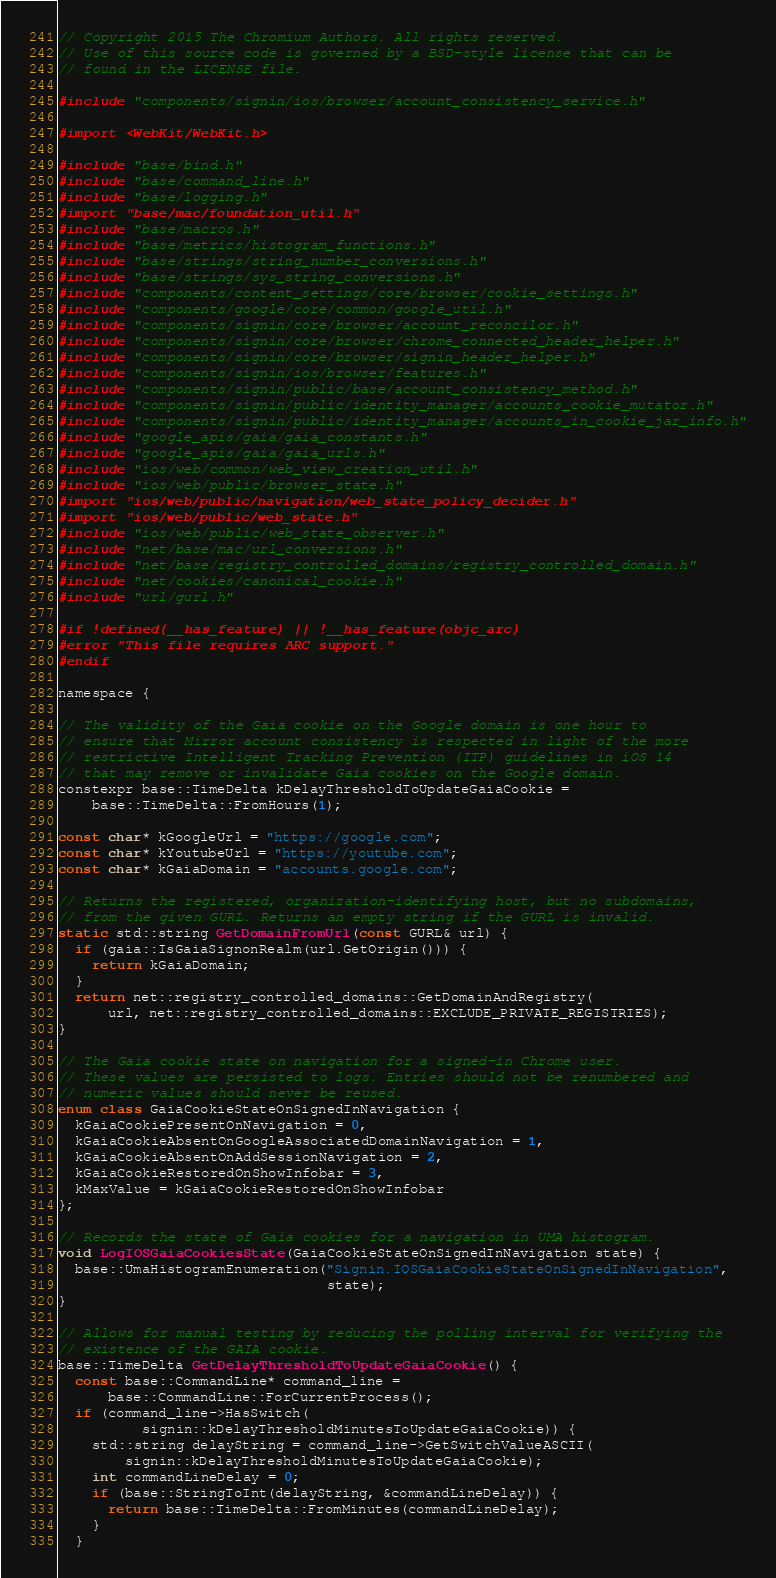<code> <loc_0><loc_0><loc_500><loc_500><_ObjectiveC_>// Copyright 2015 The Chromium Authors. All rights reserved.
// Use of this source code is governed by a BSD-style license that can be
// found in the LICENSE file.

#include "components/signin/ios/browser/account_consistency_service.h"

#import <WebKit/WebKit.h>

#include "base/bind.h"
#include "base/command_line.h"
#include "base/logging.h"
#import "base/mac/foundation_util.h"
#include "base/macros.h"
#include "base/metrics/histogram_functions.h"
#include "base/strings/string_number_conversions.h"
#include "base/strings/sys_string_conversions.h"
#include "components/content_settings/core/browser/cookie_settings.h"
#include "components/google/core/common/google_util.h"
#include "components/signin/core/browser/account_reconcilor.h"
#include "components/signin/core/browser/chrome_connected_header_helper.h"
#include "components/signin/core/browser/signin_header_helper.h"
#include "components/signin/ios/browser/features.h"
#include "components/signin/public/base/account_consistency_method.h"
#include "components/signin/public/identity_manager/accounts_cookie_mutator.h"
#include "components/signin/public/identity_manager/accounts_in_cookie_jar_info.h"
#include "google_apis/gaia/gaia_constants.h"
#include "google_apis/gaia/gaia_urls.h"
#include "ios/web/common/web_view_creation_util.h"
#include "ios/web/public/browser_state.h"
#import "ios/web/public/navigation/web_state_policy_decider.h"
#import "ios/web/public/web_state.h"
#include "ios/web/public/web_state_observer.h"
#include "net/base/mac/url_conversions.h"
#include "net/base/registry_controlled_domains/registry_controlled_domain.h"
#include "net/cookies/canonical_cookie.h"
#include "url/gurl.h"

#if !defined(__has_feature) || !__has_feature(objc_arc)
#error "This file requires ARC support."
#endif

namespace {

// The validity of the Gaia cookie on the Google domain is one hour to
// ensure that Mirror account consistency is respected in light of the more
// restrictive Intelligent Tracking Prevention (ITP) guidelines in iOS 14
// that may remove or invalidate Gaia cookies on the Google domain.
constexpr base::TimeDelta kDelayThresholdToUpdateGaiaCookie =
    base::TimeDelta::FromHours(1);

const char* kGoogleUrl = "https://google.com";
const char* kYoutubeUrl = "https://youtube.com";
const char* kGaiaDomain = "accounts.google.com";

// Returns the registered, organization-identifying host, but no subdomains,
// from the given GURL. Returns an empty string if the GURL is invalid.
static std::string GetDomainFromUrl(const GURL& url) {
  if (gaia::IsGaiaSignonRealm(url.GetOrigin())) {
    return kGaiaDomain;
  }
  return net::registry_controlled_domains::GetDomainAndRegistry(
      url, net::registry_controlled_domains::EXCLUDE_PRIVATE_REGISTRIES);
}

// The Gaia cookie state on navigation for a signed-in Chrome user.
// These values are persisted to logs. Entries should not be renumbered and
// numeric values should never be reused.
enum class GaiaCookieStateOnSignedInNavigation {
  kGaiaCookiePresentOnNavigation = 0,
  kGaiaCookieAbsentOnGoogleAssociatedDomainNavigation = 1,
  kGaiaCookieAbsentOnAddSessionNavigation = 2,
  kGaiaCookieRestoredOnShowInfobar = 3,
  kMaxValue = kGaiaCookieRestoredOnShowInfobar
};

// Records the state of Gaia cookies for a navigation in UMA histogram.
void LogIOSGaiaCookiesState(GaiaCookieStateOnSignedInNavigation state) {
  base::UmaHistogramEnumeration("Signin.IOSGaiaCookieStateOnSignedInNavigation",
                                state);
}

// Allows for manual testing by reducing the polling interval for verifying the
// existence of the GAIA cookie.
base::TimeDelta GetDelayThresholdToUpdateGaiaCookie() {
  const base::CommandLine* command_line =
      base::CommandLine::ForCurrentProcess();
  if (command_line->HasSwitch(
          signin::kDelayThresholdMinutesToUpdateGaiaCookie)) {
    std::string delayString = command_line->GetSwitchValueASCII(
        signin::kDelayThresholdMinutesToUpdateGaiaCookie);
    int commandLineDelay = 0;
    if (base::StringToInt(delayString, &commandLineDelay)) {
      return base::TimeDelta::FromMinutes(commandLineDelay);
    }
  }</code> 